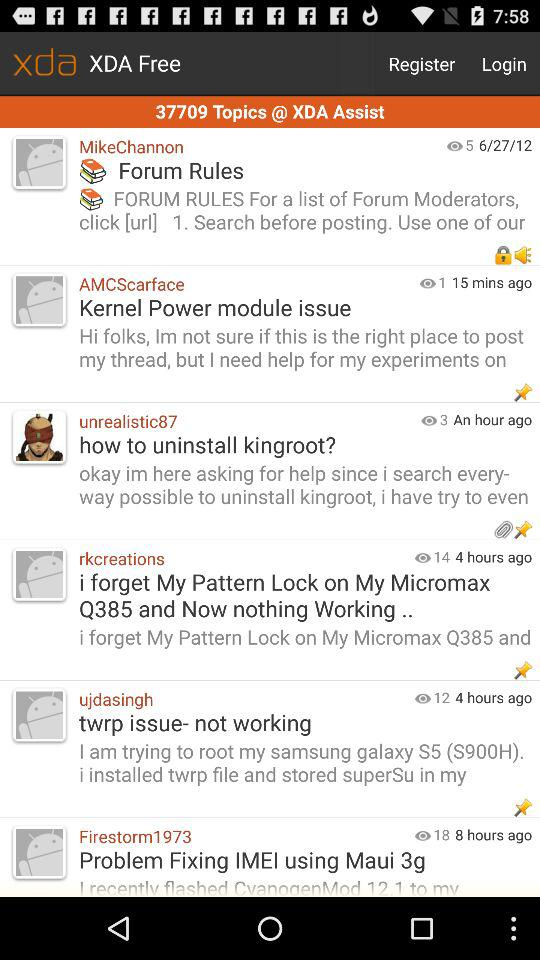How many hours ago did "rkcreations" post? "rkcreations" posted 4 hours ago. 